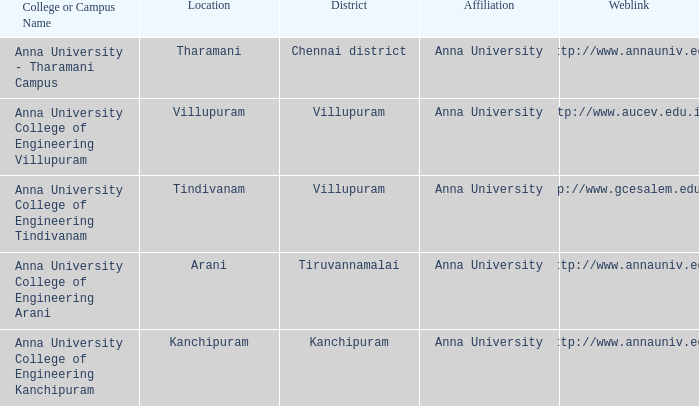What internet link contains a college or campus name of anna university college of engineering tindivanam? Http://www.gcesalem.edu.in. 